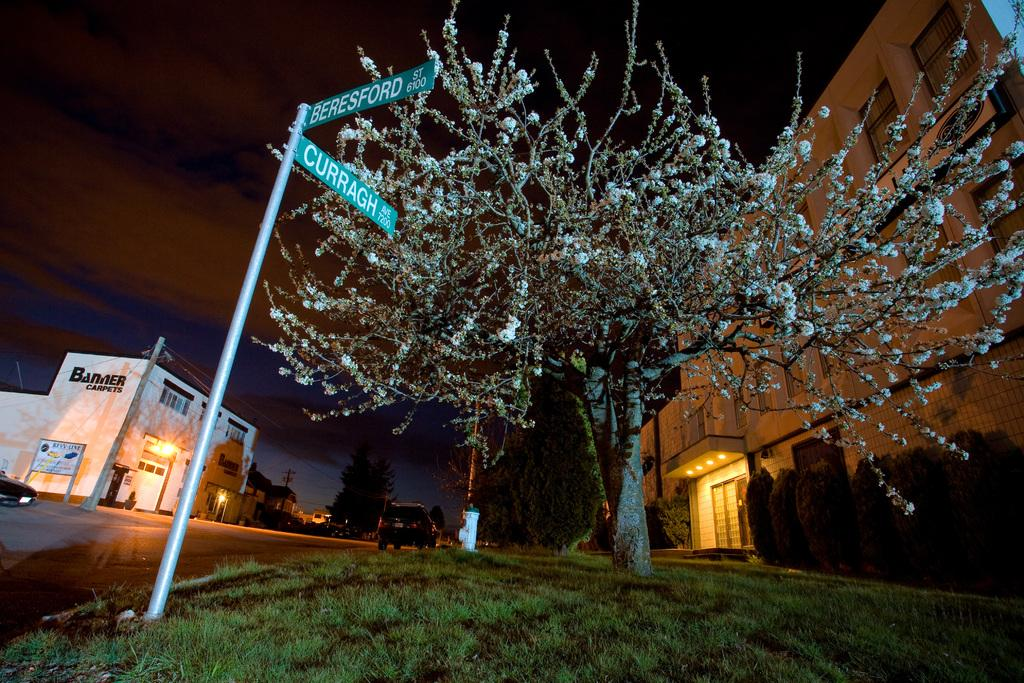What type of natural elements can be seen in the image? There are trees in the image. What type of man-made structures are present in the image? There are buildings in the image. What type of illumination is visible in the image? There are lights in the image. What type of vegetation, other than trees, can be seen in the image? There are shrubs in the image. What type of infrastructure is present in the image? There are poles with wires in the image. What type of signage is present in the image? There are boards in the image. What type of transportation is visible in the image? There are vehicles on the road in the image. What part of the natural environment is visible in the image? The sky is visible at the top of the image. What type of lamp is hanging from the side of the building in the image? There is no lamp hanging from the side of a building in the image. What type of current is flowing through the wires in the image? There is no indication of the type of current flowing through the wires in the image. 